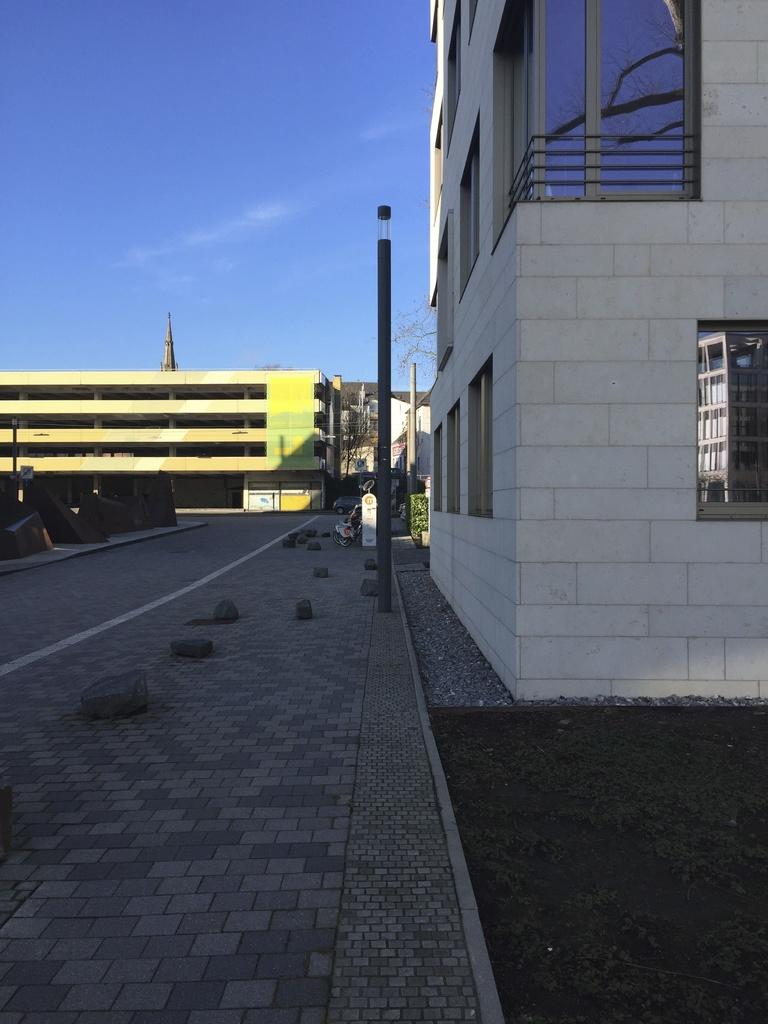What type of vegetation can be seen in the image? There is grass, plants, and trees visible in the image. What type of structures are present in the image? There are buildings, a tower, and a fence in the image. What other objects can be seen in the image? There are poles and windows visible in the image. What is visible in the background of the image? The sky is visible in the image. Can you describe the setting of the image? The image may have been taken on a road, as suggested by the presence of buildings and poles. What type of suit is the coal wearing in the image? There is no suit or coal present in the image. What type of drink is being served in the image? There is no drink being served in the image. 